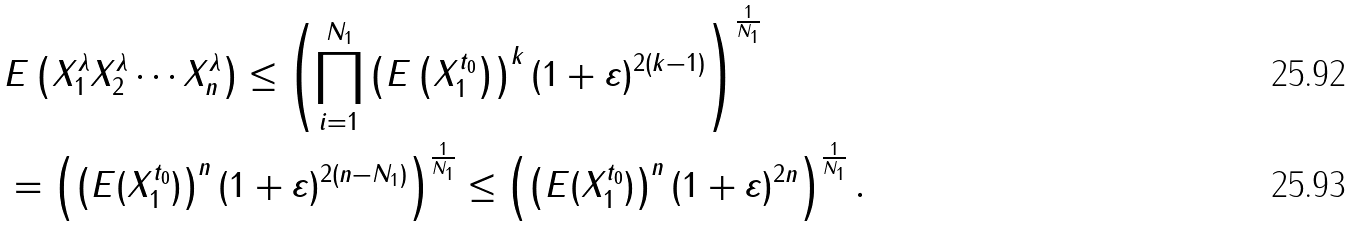<formula> <loc_0><loc_0><loc_500><loc_500>& E \left ( X _ { 1 } ^ { \lambda } X _ { 2 } ^ { \lambda } \cdots X _ { n } ^ { \lambda } \right ) \leq \left ( \prod _ { i = 1 } ^ { N _ { 1 } } \left ( E \left ( X _ { 1 } ^ { t _ { 0 } } \right ) \right ) ^ { k } ( 1 + \varepsilon ) ^ { 2 ( k - 1 ) } \right ) ^ { \frac { 1 } { N _ { 1 } } } \\ & = \left ( \left ( E ( X _ { 1 } ^ { t _ { 0 } } ) \right ) ^ { n } ( 1 + \varepsilon ) ^ { 2 ( n - N _ { 1 } ) } \right ) ^ { \frac { 1 } { N _ { 1 } } } \leq \left ( \left ( E ( X _ { 1 } ^ { t _ { 0 } } ) \right ) ^ { n } ( 1 + \varepsilon ) ^ { 2 n } \right ) ^ { \frac { 1 } { N _ { 1 } } } .</formula> 